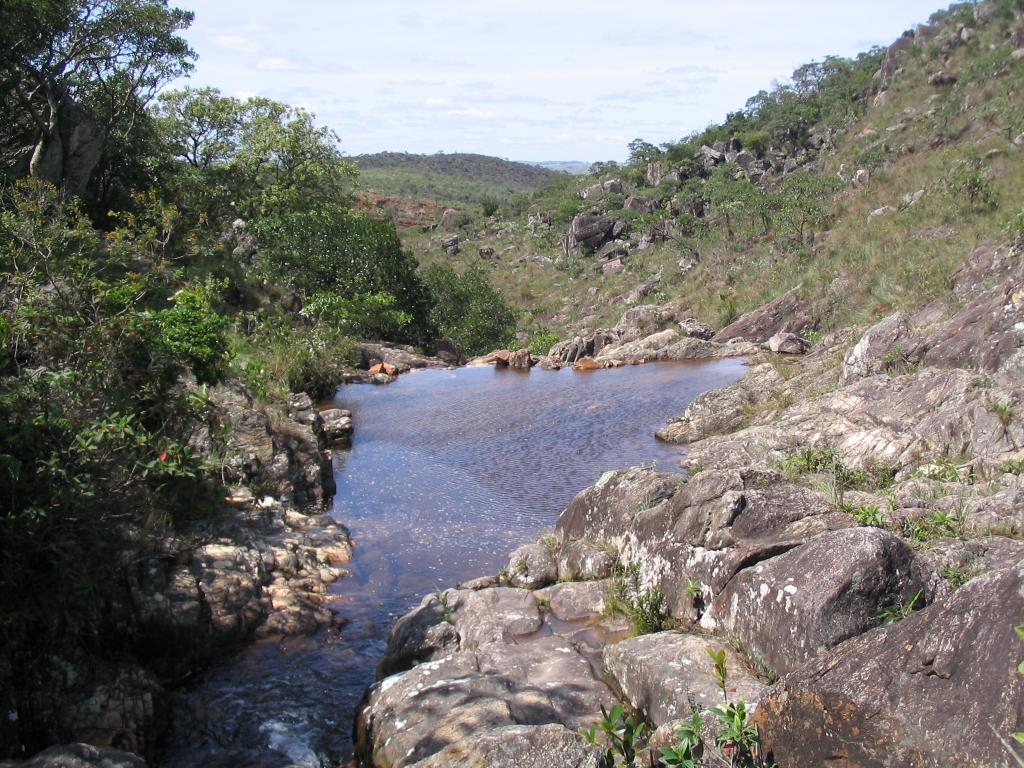What is the primary element visible in the image? There is water in the image. What surrounds the water in the image? There are rocks around the water. What can be seen in the background of the image? There are trees and rocks in the background of the image. How does the water start to boil in the image? The water does not start to boil in the image; there is no indication of heat or boiling. 